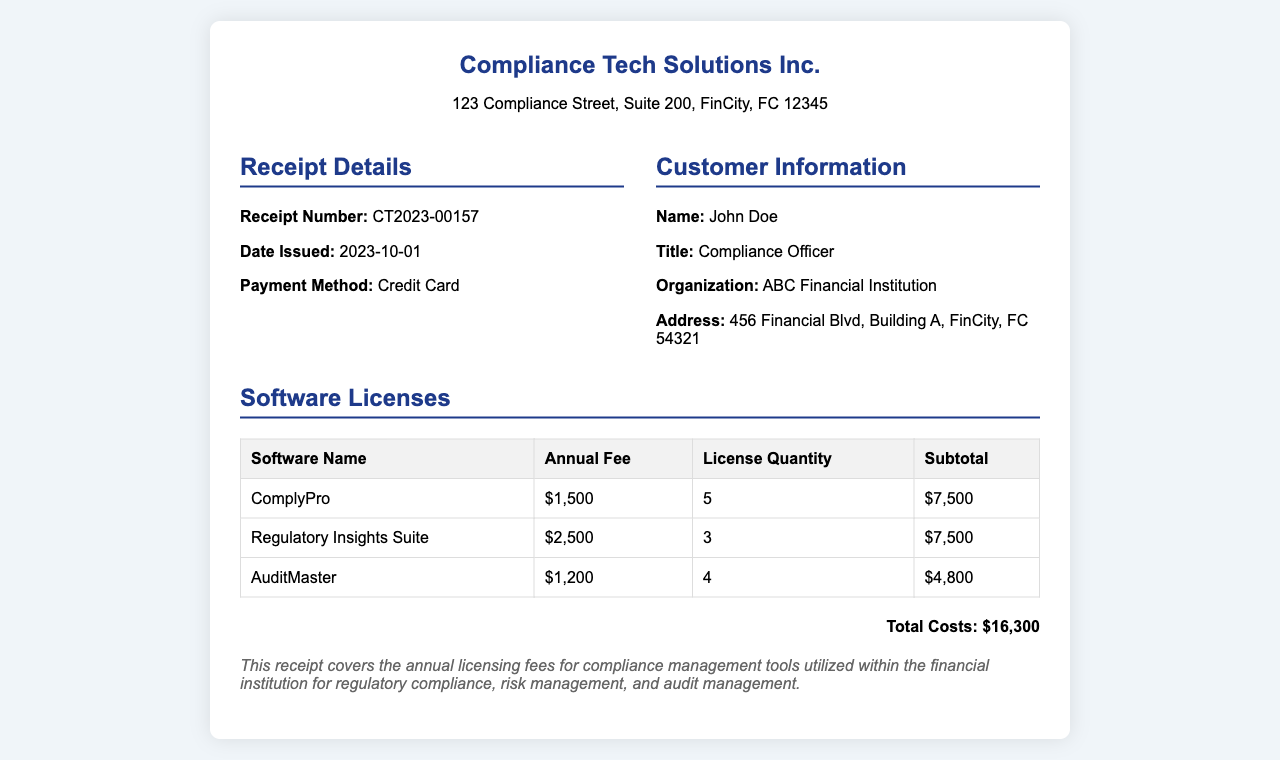What is the receipt number? The receipt number is a specific identifier found in the document, listed under receipt details.
Answer: CT2023-00157 What is the date issued? The date issued is the specific date when the receipt was created, as shown in the receipt details.
Answer: 2023-10-01 Who is the customer? The customer is identified in the receipt under customer information, including their name, title, and organization.
Answer: John Doe What is the total cost? The total cost is calculated from the sum of all software license fees listed in the document.
Answer: $16,300 How many licenses of ComplyPro were purchased? The license quantity for ComplyPro is listed in the software licenses section, indicating the number of licenses acquired.
Answer: 5 What is the annual fee for AuditMaster? The annual fee for AuditMaster is specifically stated in the software licenses table under the fees and costs.
Answer: $1,200 What organization is listed as the customer? The organization can be found within the customer information section of the receipt.
Answer: ABC Financial Institution What payment method was used? The payment method is specified in the receipt details, indicating how the transaction was completed.
Answer: Credit Card Which software has the highest annual fee? This question requires comparison between the fees for all listed software in the table to determine which is the highest.
Answer: Regulatory Insights Suite 